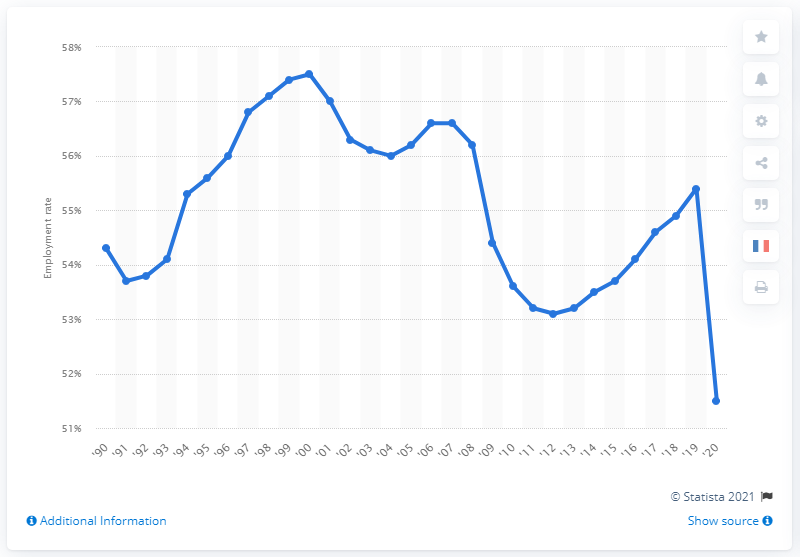Highlight a few significant elements in this photo. The highest female employment rate in 2000 was 57%. The female employment rate in 2020 was 51.5%. In 1990, the female employment rate was 54.6%. 